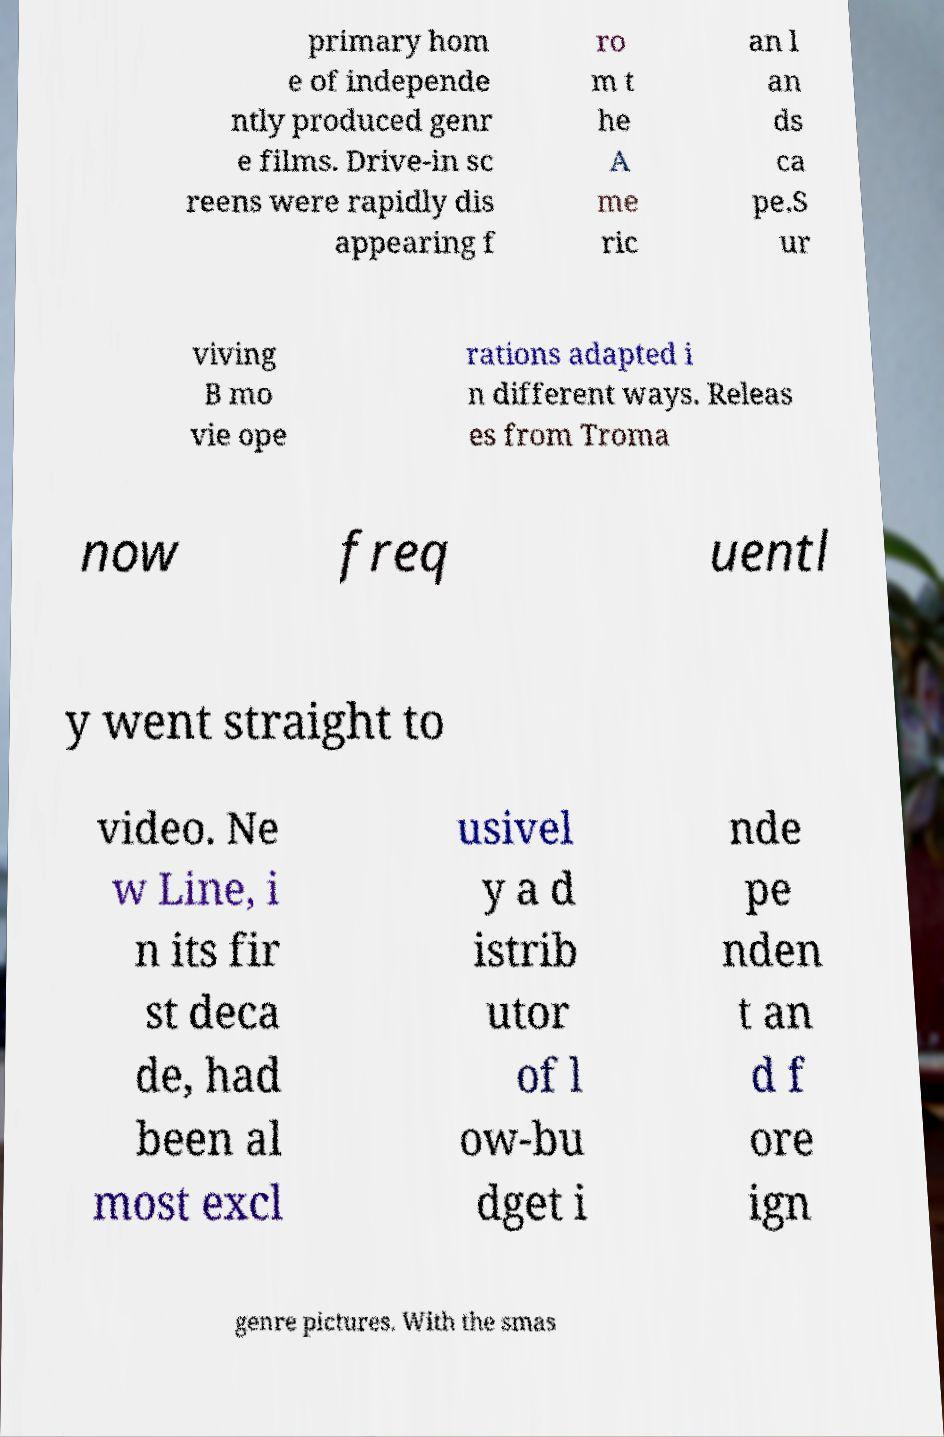What messages or text are displayed in this image? I need them in a readable, typed format. primary hom e of independe ntly produced genr e films. Drive-in sc reens were rapidly dis appearing f ro m t he A me ric an l an ds ca pe.S ur viving B mo vie ope rations adapted i n different ways. Releas es from Troma now freq uentl y went straight to video. Ne w Line, i n its fir st deca de, had been al most excl usivel y a d istrib utor of l ow-bu dget i nde pe nden t an d f ore ign genre pictures. With the smas 